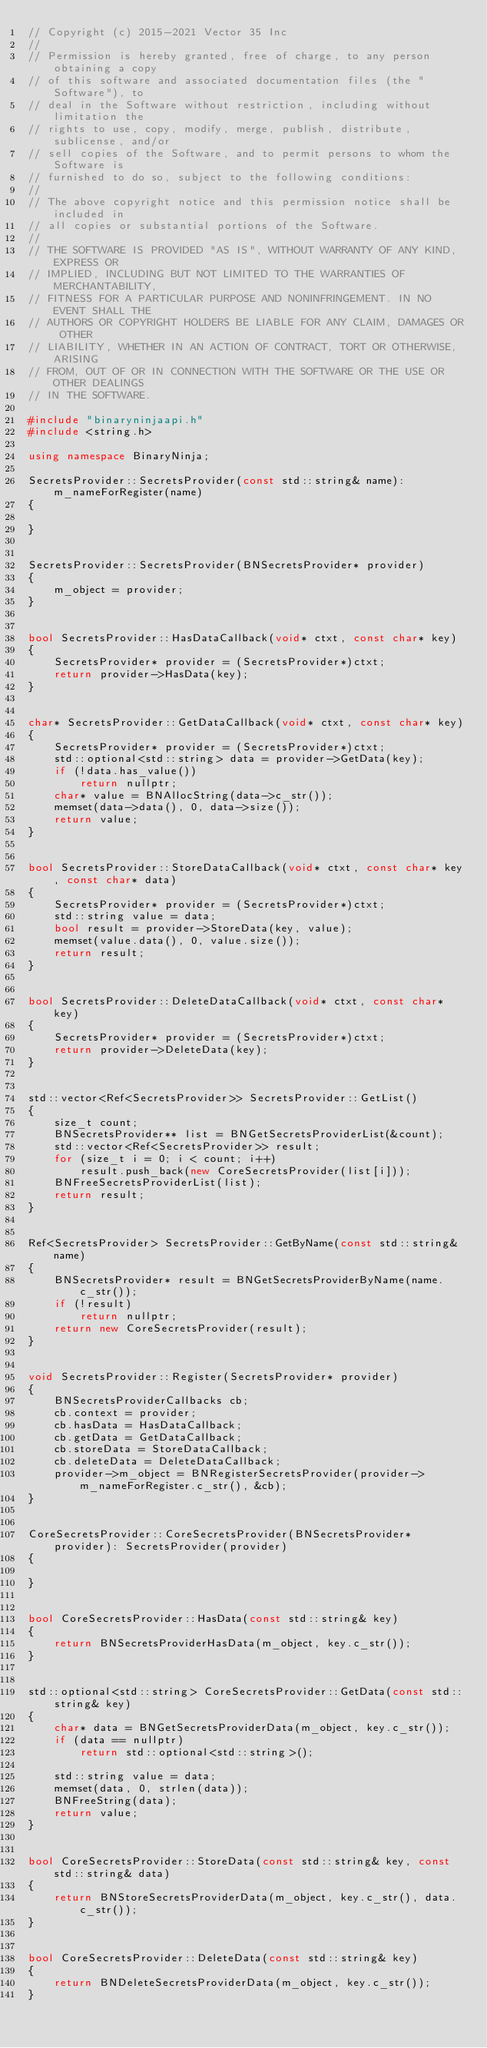Convert code to text. <code><loc_0><loc_0><loc_500><loc_500><_C++_>// Copyright (c) 2015-2021 Vector 35 Inc
//
// Permission is hereby granted, free of charge, to any person obtaining a copy
// of this software and associated documentation files (the "Software"), to
// deal in the Software without restriction, including without limitation the
// rights to use, copy, modify, merge, publish, distribute, sublicense, and/or
// sell copies of the Software, and to permit persons to whom the Software is
// furnished to do so, subject to the following conditions:
//
// The above copyright notice and this permission notice shall be included in
// all copies or substantial portions of the Software.
//
// THE SOFTWARE IS PROVIDED "AS IS", WITHOUT WARRANTY OF ANY KIND, EXPRESS OR
// IMPLIED, INCLUDING BUT NOT LIMITED TO THE WARRANTIES OF MERCHANTABILITY,
// FITNESS FOR A PARTICULAR PURPOSE AND NONINFRINGEMENT. IN NO EVENT SHALL THE
// AUTHORS OR COPYRIGHT HOLDERS BE LIABLE FOR ANY CLAIM, DAMAGES OR OTHER
// LIABILITY, WHETHER IN AN ACTION OF CONTRACT, TORT OR OTHERWISE, ARISING
// FROM, OUT OF OR IN CONNECTION WITH THE SOFTWARE OR THE USE OR OTHER DEALINGS
// IN THE SOFTWARE.

#include "binaryninjaapi.h"
#include <string.h>

using namespace BinaryNinja;

SecretsProvider::SecretsProvider(const std::string& name): m_nameForRegister(name)
{

}


SecretsProvider::SecretsProvider(BNSecretsProvider* provider)
{
	m_object = provider;
}


bool SecretsProvider::HasDataCallback(void* ctxt, const char* key)
{
	SecretsProvider* provider = (SecretsProvider*)ctxt;
	return provider->HasData(key);
}


char* SecretsProvider::GetDataCallback(void* ctxt, const char* key)
{
	SecretsProvider* provider = (SecretsProvider*)ctxt;
	std::optional<std::string> data = provider->GetData(key);
	if (!data.has_value())
		return nullptr;
	char* value = BNAllocString(data->c_str());
	memset(data->data(), 0, data->size());
	return value;
}


bool SecretsProvider::StoreDataCallback(void* ctxt, const char* key, const char* data)
{
	SecretsProvider* provider = (SecretsProvider*)ctxt;
	std::string value = data;
	bool result = provider->StoreData(key, value);
	memset(value.data(), 0, value.size());
	return result;
}


bool SecretsProvider::DeleteDataCallback(void* ctxt, const char* key)
{
	SecretsProvider* provider = (SecretsProvider*)ctxt;
	return provider->DeleteData(key);
}


std::vector<Ref<SecretsProvider>> SecretsProvider::GetList()
{
	size_t count;
	BNSecretsProvider** list = BNGetSecretsProviderList(&count);
	std::vector<Ref<SecretsProvider>> result;
	for (size_t i = 0; i < count; i++)
		result.push_back(new CoreSecretsProvider(list[i]));
	BNFreeSecretsProviderList(list);
	return result;
}


Ref<SecretsProvider> SecretsProvider::GetByName(const std::string& name)
{
	BNSecretsProvider* result = BNGetSecretsProviderByName(name.c_str());
	if (!result)
		return nullptr;
	return new CoreSecretsProvider(result);
}


void SecretsProvider::Register(SecretsProvider* provider)
{
	BNSecretsProviderCallbacks cb;
	cb.context = provider;
	cb.hasData = HasDataCallback;
	cb.getData = GetDataCallback;
	cb.storeData = StoreDataCallback;
	cb.deleteData = DeleteDataCallback;
	provider->m_object = BNRegisterSecretsProvider(provider->m_nameForRegister.c_str(), &cb);
}


CoreSecretsProvider::CoreSecretsProvider(BNSecretsProvider* provider): SecretsProvider(provider)
{

}


bool CoreSecretsProvider::HasData(const std::string& key)
{
	return BNSecretsProviderHasData(m_object, key.c_str());
}


std::optional<std::string> CoreSecretsProvider::GetData(const std::string& key)
{
	char* data = BNGetSecretsProviderData(m_object, key.c_str());
	if (data == nullptr)
		return std::optional<std::string>();

	std::string value = data;
	memset(data, 0, strlen(data));
	BNFreeString(data);
	return value;
}


bool CoreSecretsProvider::StoreData(const std::string& key, const std::string& data)
{
	return BNStoreSecretsProviderData(m_object, key.c_str(), data.c_str());
}


bool CoreSecretsProvider::DeleteData(const std::string& key)
{
	return BNDeleteSecretsProviderData(m_object, key.c_str());
}
</code> 